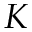<formula> <loc_0><loc_0><loc_500><loc_500>K</formula> 